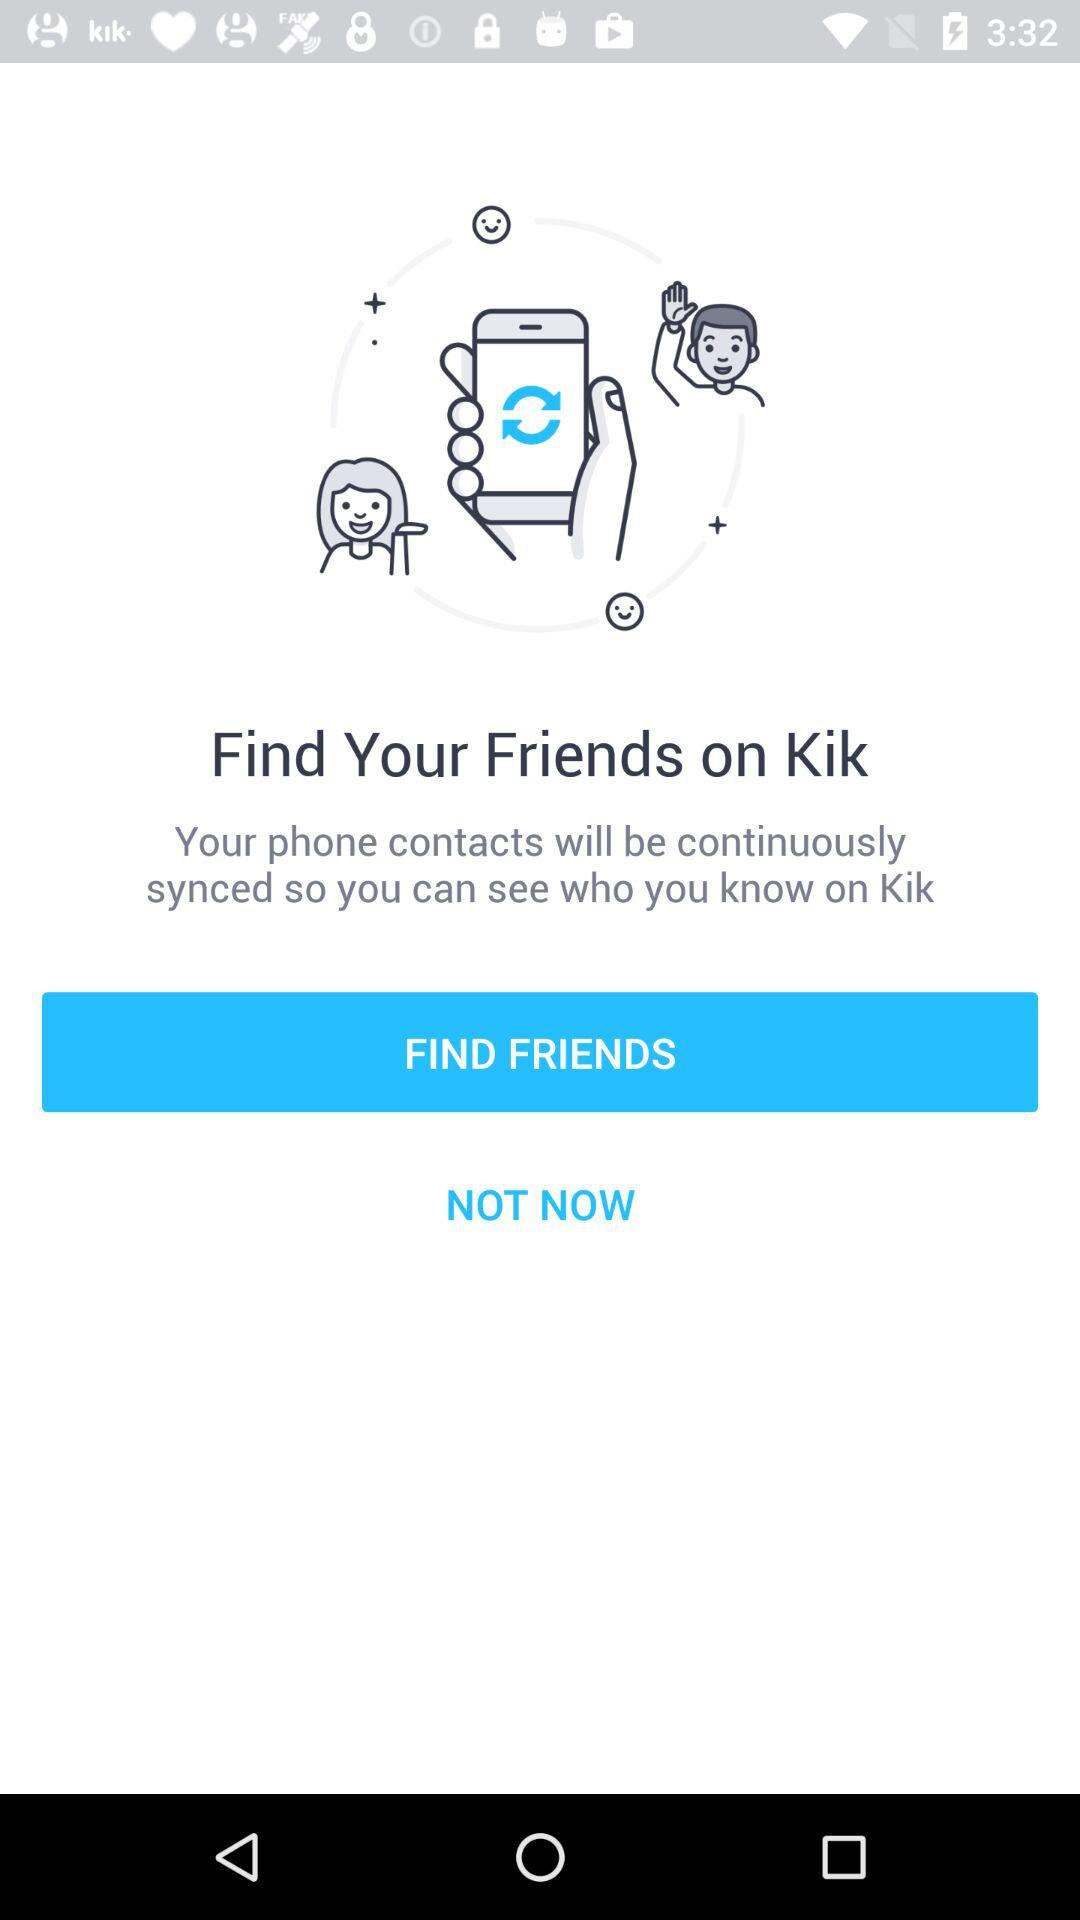Where to find friends? You can find friends on Kik. 